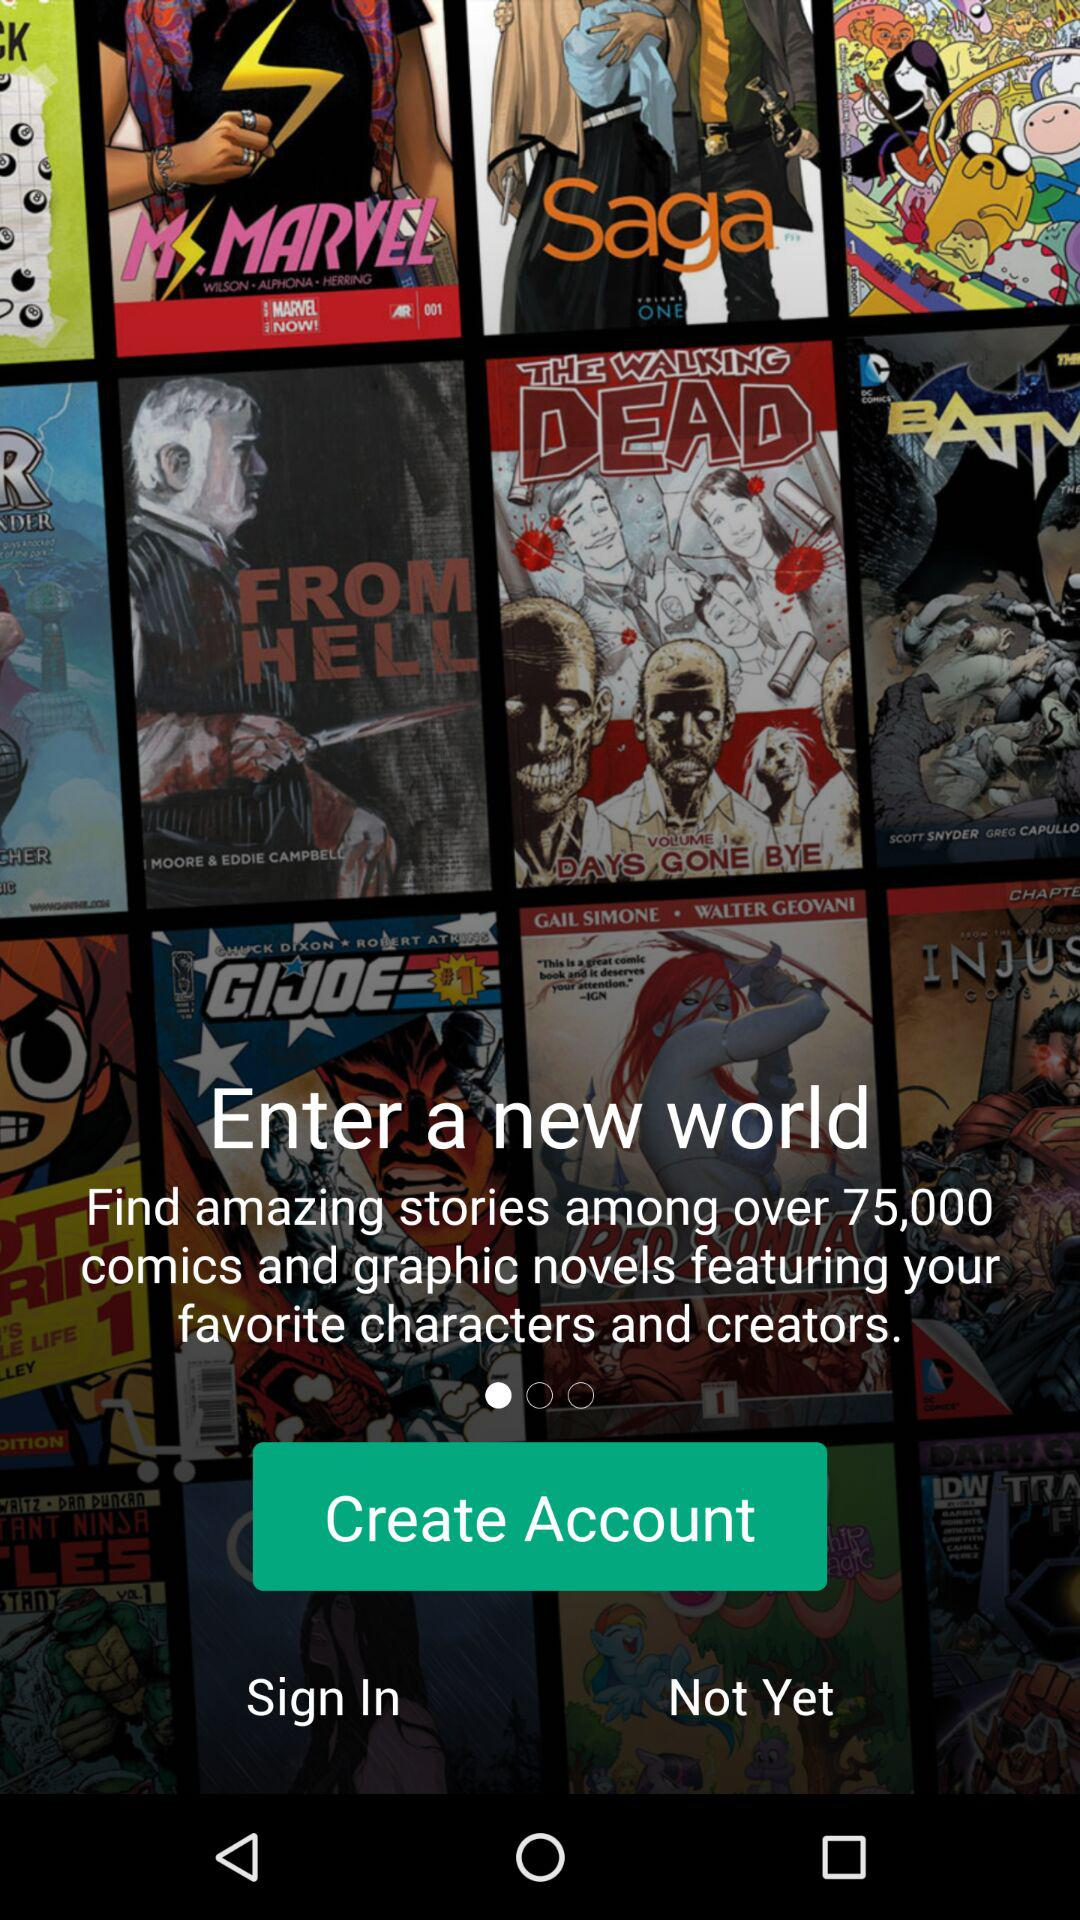How many comics and graphic novels are there? There are over 75,000 comics and graphic novels. 